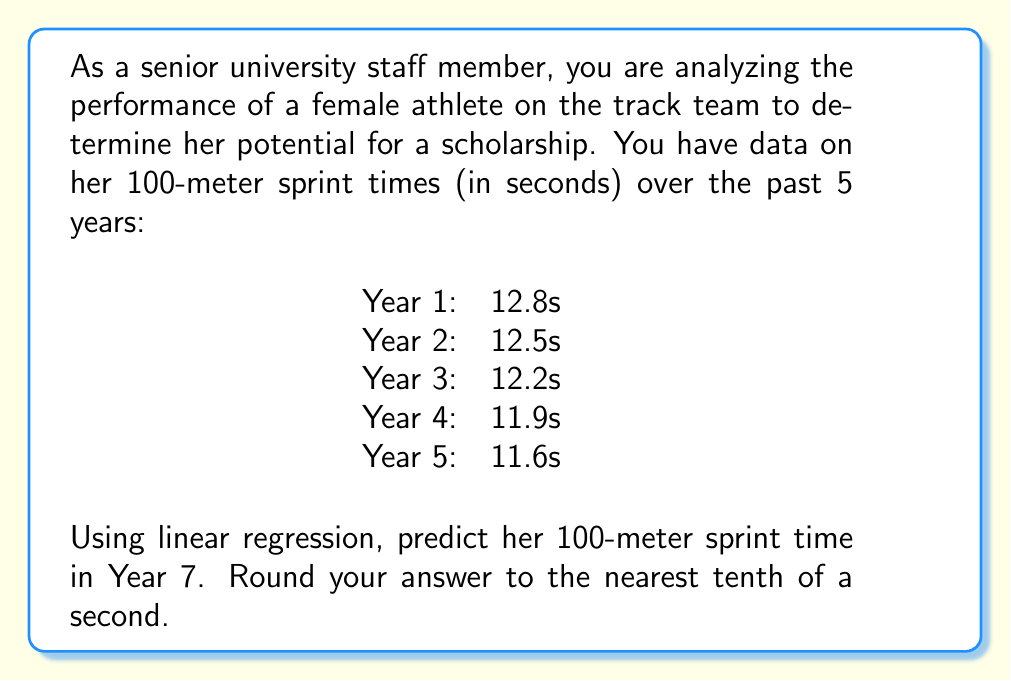Could you help me with this problem? To solve this problem, we'll use linear regression to find the line of best fit for the given data points and then use that line to predict the athlete's time in Year 7.

1. First, let's set up our data points:
   x (Year): 1, 2, 3, 4, 5
   y (Time): 12.8, 12.5, 12.2, 11.9, 11.6

2. We'll use the following formulas for linear regression:
   $$m = \frac{n\sum(xy) - \sum(x)\sum(y)}{n\sum(x^2) - (\sum(x))^2}$$
   $$b = \bar{y} - m\bar{x}$$

   Where $m$ is the slope, $b$ is the y-intercept, $n$ is the number of data points, and $\bar{x}$ and $\bar{y}$ are the means of x and y respectively.

3. Calculate the required sums:
   $n = 5$
   $\sum(x) = 1 + 2 + 3 + 4 + 5 = 15$
   $\sum(y) = 12.8 + 12.5 + 12.2 + 11.9 + 11.6 = 61$
   $\sum(xy) = (1)(12.8) + (2)(12.5) + (3)(12.2) + (4)(11.9) + (5)(11.6) = 178.6$
   $\sum(x^2) = 1^2 + 2^2 + 3^2 + 4^2 + 5^2 = 55$

4. Calculate the slope $m$:
   $$m = \frac{5(178.6) - (15)(61)}{5(55) - (15)^2} = \frac{893 - 915}{275 - 225} = \frac{-22}{50} = -0.44$$

5. Calculate $\bar{x}$ and $\bar{y}$:
   $\bar{x} = \frac{\sum(x)}{n} = \frac{15}{5} = 3$
   $\bar{y} = \frac{\sum(y)}{n} = \frac{61}{5} = 12.2$

6. Calculate the y-intercept $b$:
   $$b = 12.2 - (-0.44)(3) = 12.2 + 1.32 = 13.52$$

7. Our linear regression equation is:
   $$y = -0.44x + 13.52$$

8. To predict the time for Year 7, we substitute $x = 7$ into our equation:
   $$y = -0.44(7) + 13.52 = -3.08 + 13.52 = 10.44$$

9. Rounding to the nearest tenth of a second, we get 10.4 seconds.
Answer: 10.4 seconds 